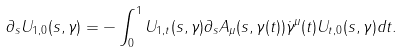<formula> <loc_0><loc_0><loc_500><loc_500>\partial _ { s } U _ { 1 , 0 } ( s , \gamma ) = - \int _ { 0 } ^ { 1 } U _ { 1 , t } ( s , \gamma ) \partial _ { s } A _ { \mu } ( s , \gamma ( t ) ) \dot { \gamma } ^ { \mu } ( t ) U _ { t , 0 } ( s , \gamma ) d t .</formula> 